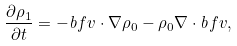<formula> <loc_0><loc_0><loc_500><loc_500>\frac { \partial \rho _ { 1 } } { \partial t } = - \mathit b f { v } \cdot \nabla \rho _ { 0 } - \rho _ { 0 } \nabla \cdot \mathit b f { v } ,</formula> 